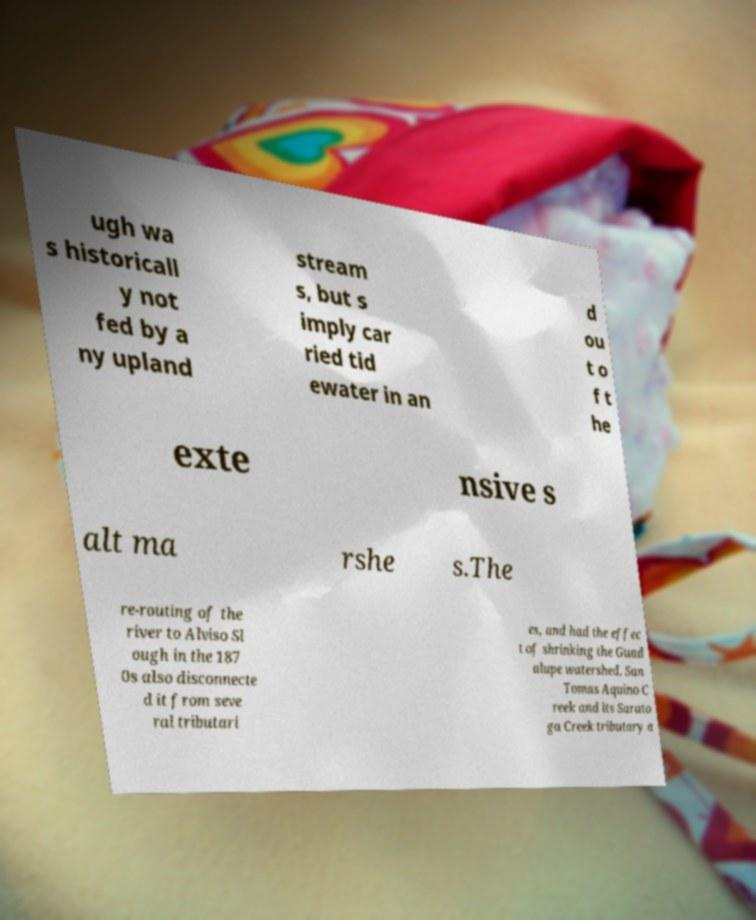Could you assist in decoding the text presented in this image and type it out clearly? ugh wa s historicall y not fed by a ny upland stream s, but s imply car ried tid ewater in an d ou t o f t he exte nsive s alt ma rshe s.The re-routing of the river to Alviso Sl ough in the 187 0s also disconnecte d it from seve ral tributari es, and had the effec t of shrinking the Guad alupe watershed. San Tomas Aquino C reek and its Sarato ga Creek tributary a 